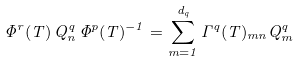<formula> <loc_0><loc_0><loc_500><loc_500>\Phi ^ { r } ( T ) \, Q ^ { q } _ { n } \, \Phi ^ { p } ( T ) ^ { - 1 } = \sum _ { m = 1 } ^ { d _ { q } } \Gamma ^ { q } ( T ) _ { m n } Q ^ { q } _ { m }</formula> 